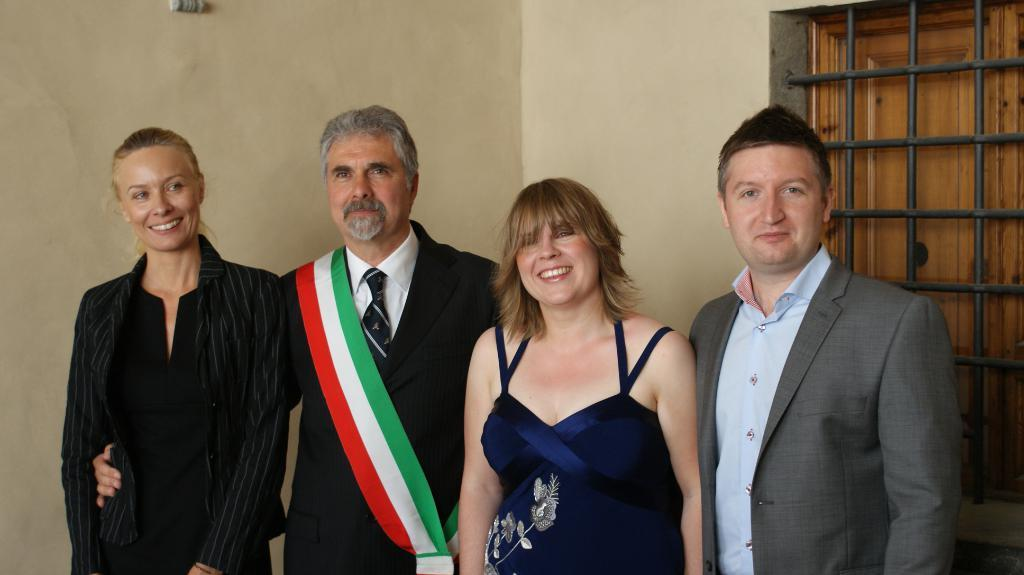What is the main subject of the image? The main subject of the image is a group of people. What can be seen on the right side of the image? There is a window on the right side of the image. What is visible in the background of the image? There is a wall visible in the background of the image. What type of waves can be seen crashing against the earth in the image? There are no waves or earth present in the image; it features a group of people and a window on the right side. 